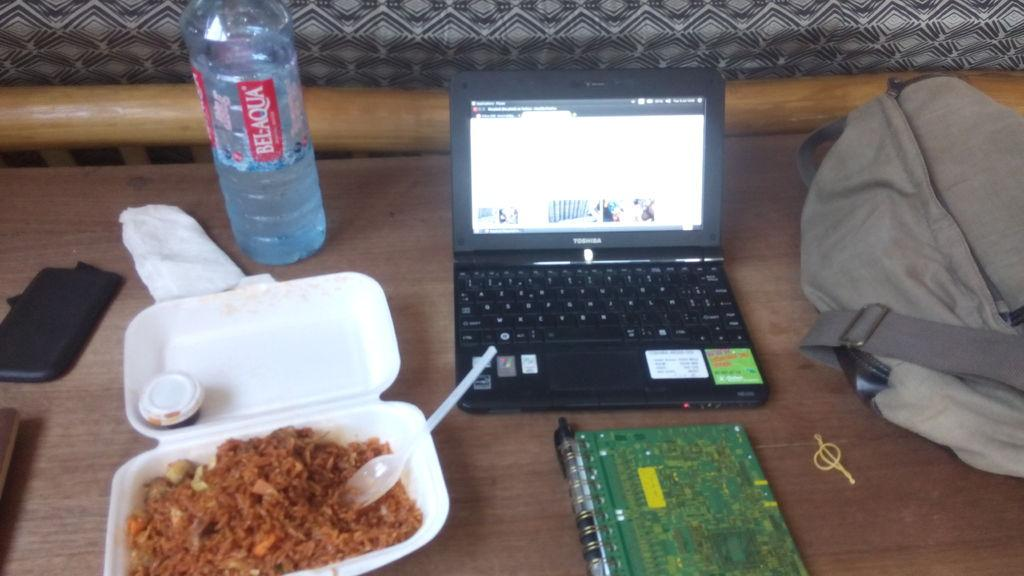Where is the image taken? The image is taken on a table. What objects can be seen on the table? There is a box, a spoon, a water bottle, a laptop, a book, a pen, a bag, and some eatables on the table. What might be used for writing or drawing on the table? A pen is present on the table for writing or drawing. What can be used for consuming the eatables on the table? A spoon is present on the table for consuming the eatables. What type of bed can be seen in the image? There is no bed present in the image; it is taken on a table with various objects. How many things are there on the table that are not mentioned in the facts? There are no additional objects present in the image that are not mentioned in the facts. 